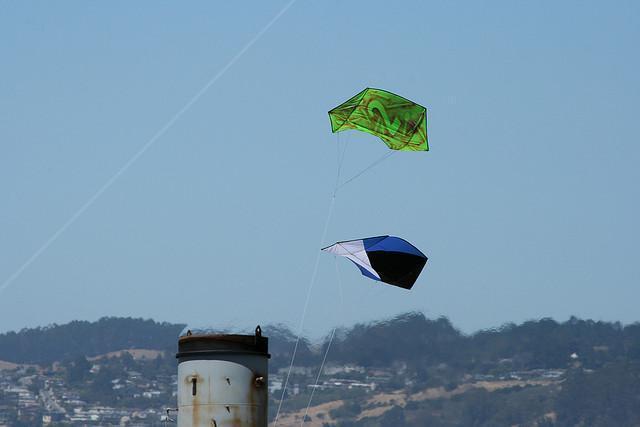How many kites can you see?
Give a very brief answer. 2. 